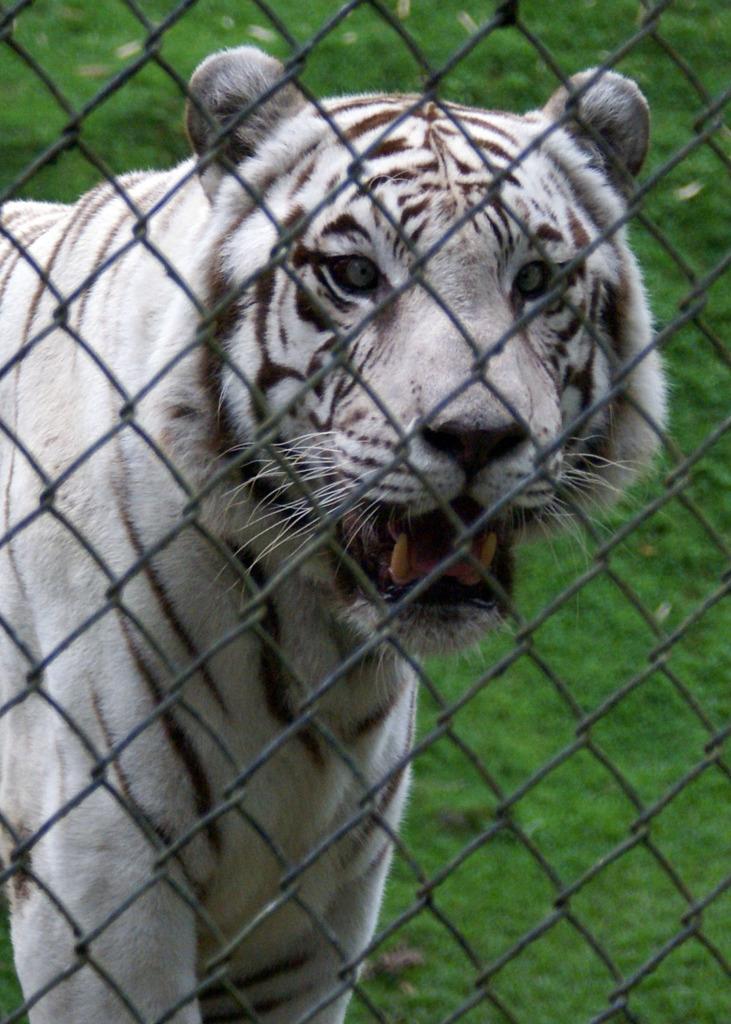Can you describe this image briefly? In this image I can see a tiger, in front of it there is a net. In the background can see the grass on the ground. 